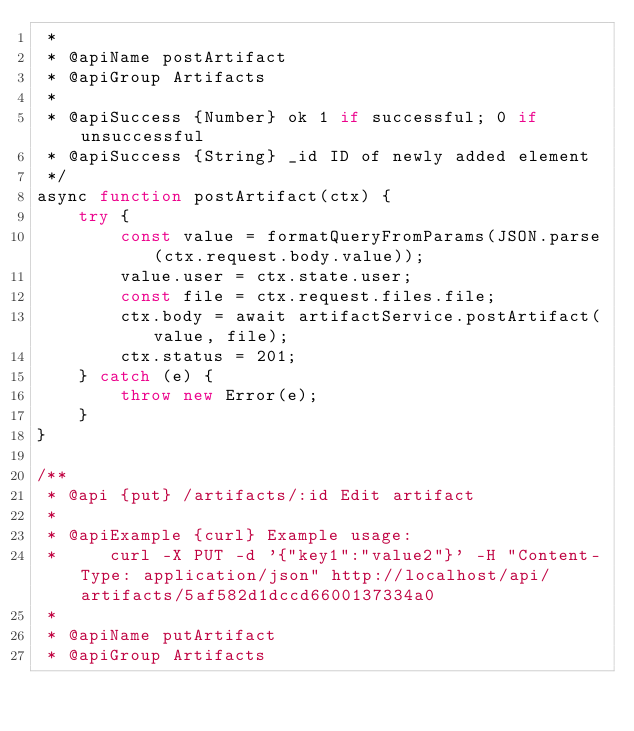<code> <loc_0><loc_0><loc_500><loc_500><_JavaScript_> * 
 * @apiName postArtifact
 * @apiGroup Artifacts
 * 
 * @apiSuccess {Number} ok 1 if successful; 0 if unsuccessful
 * @apiSuccess {String} _id ID of newly added element
 */
async function postArtifact(ctx) {
    try {
        const value = formatQueryFromParams(JSON.parse(ctx.request.body.value));
        value.user = ctx.state.user;
        const file = ctx.request.files.file;
        ctx.body = await artifactService.postArtifact(value, file);
        ctx.status = 201;
    } catch (e) {
        throw new Error(e);
    }
}

/**
 * @api {put} /artifacts/:id Edit artifact
 * 
 * @apiExample {curl} Example usage:
 *     curl -X PUT -d '{"key1":"value2"}' -H "Content-Type: application/json" http://localhost/api/artifacts/5af582d1dccd6600137334a0 
 * 
 * @apiName putArtifact
 * @apiGroup Artifacts</code> 